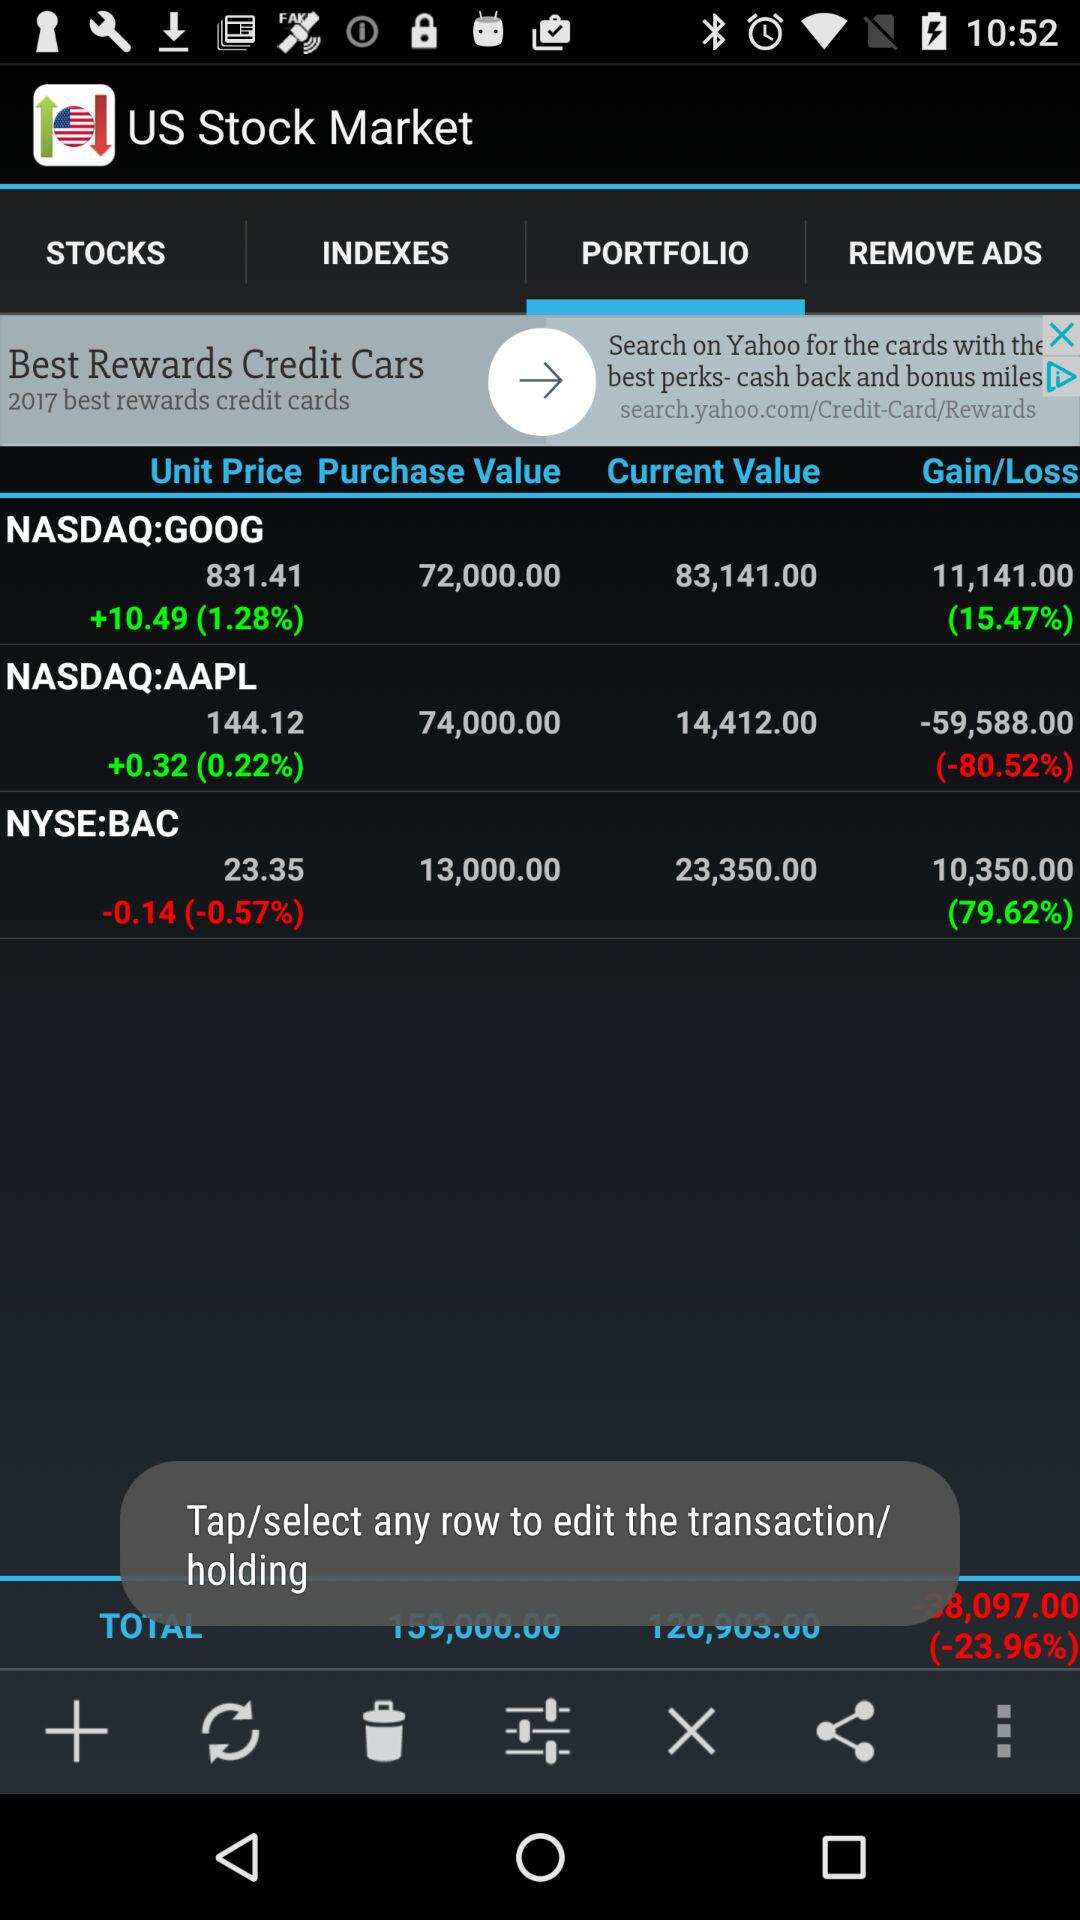Which tab are we on? You are on the "PORTFOLIO" tab. 